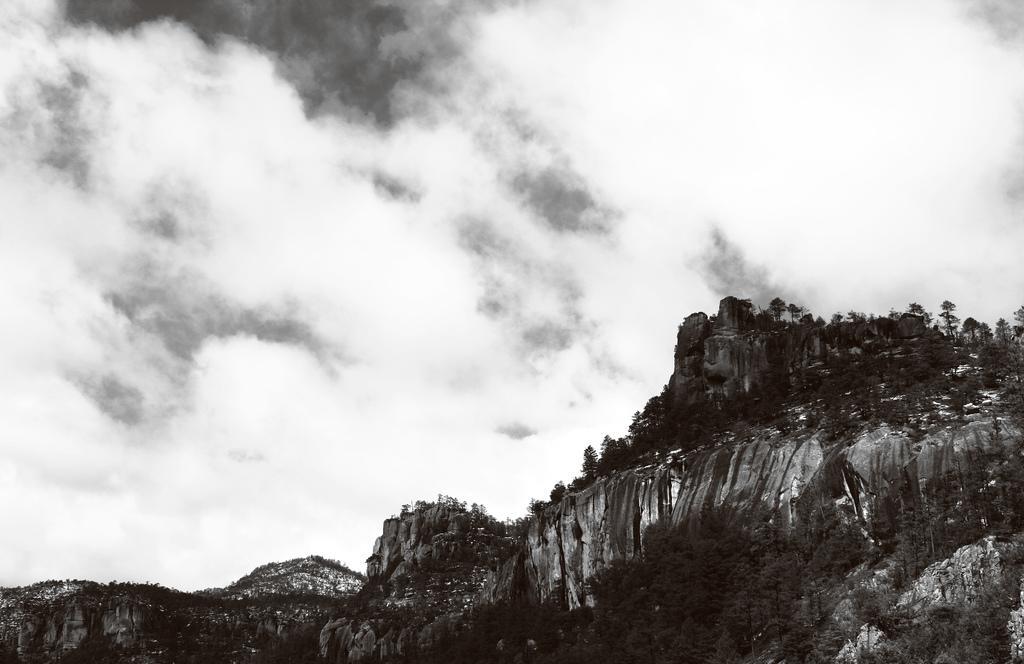Describe this image in one or two sentences. In this image I can see number of trees and clouds. I can also see this image is black and white in colour. 